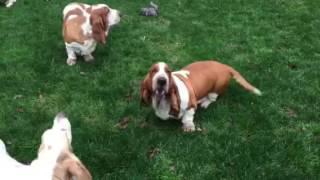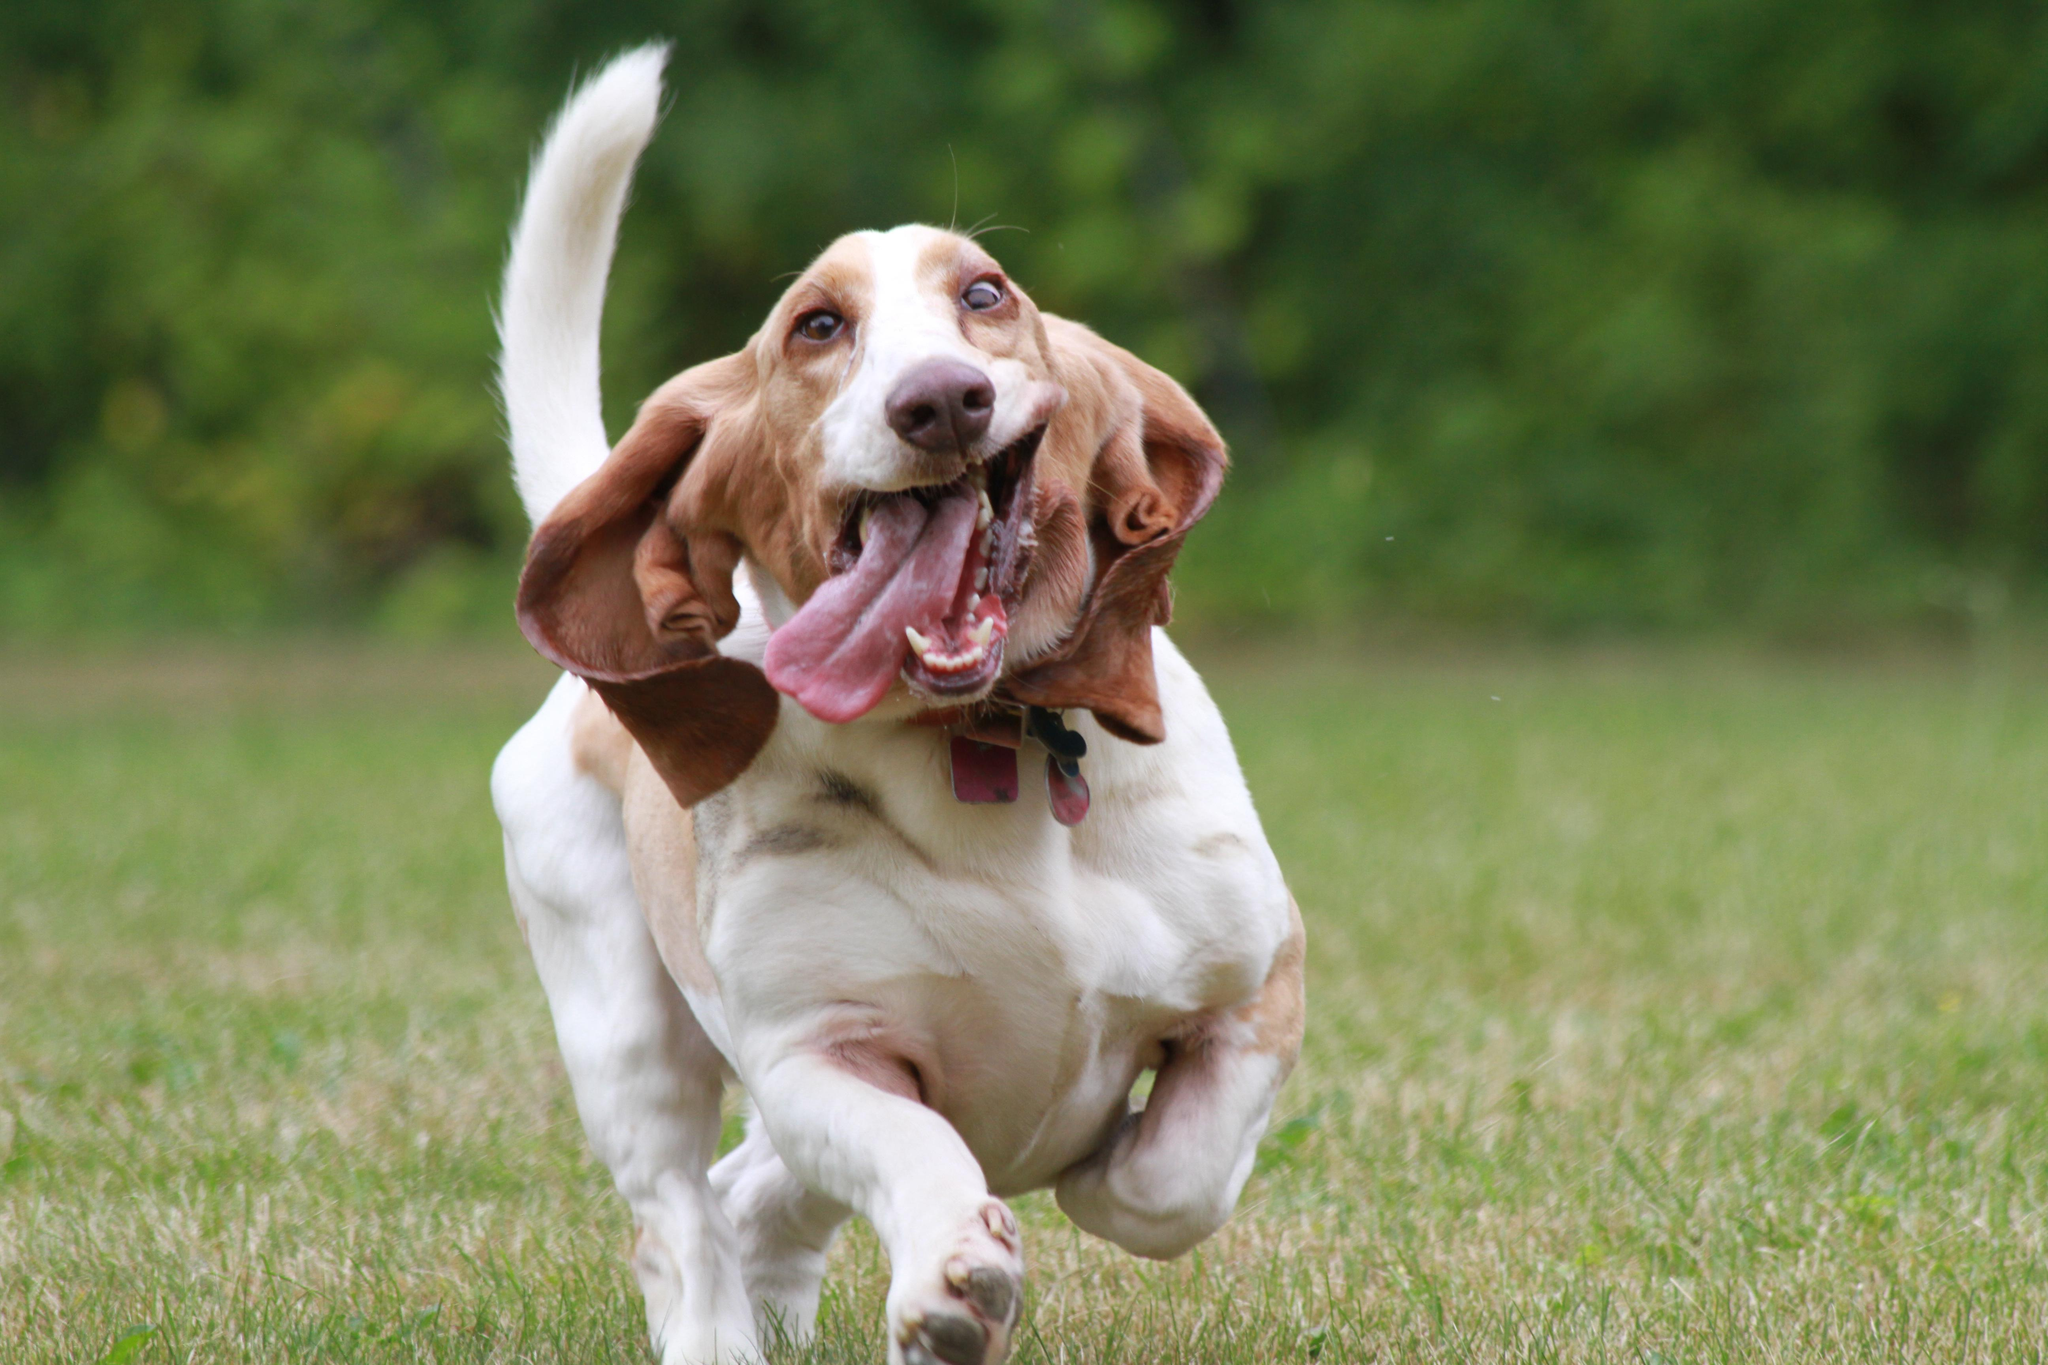The first image is the image on the left, the second image is the image on the right. Examine the images to the left and right. Is the description "Every dog on the left is young, every dog on the right is adult." accurate? Answer yes or no. No. 